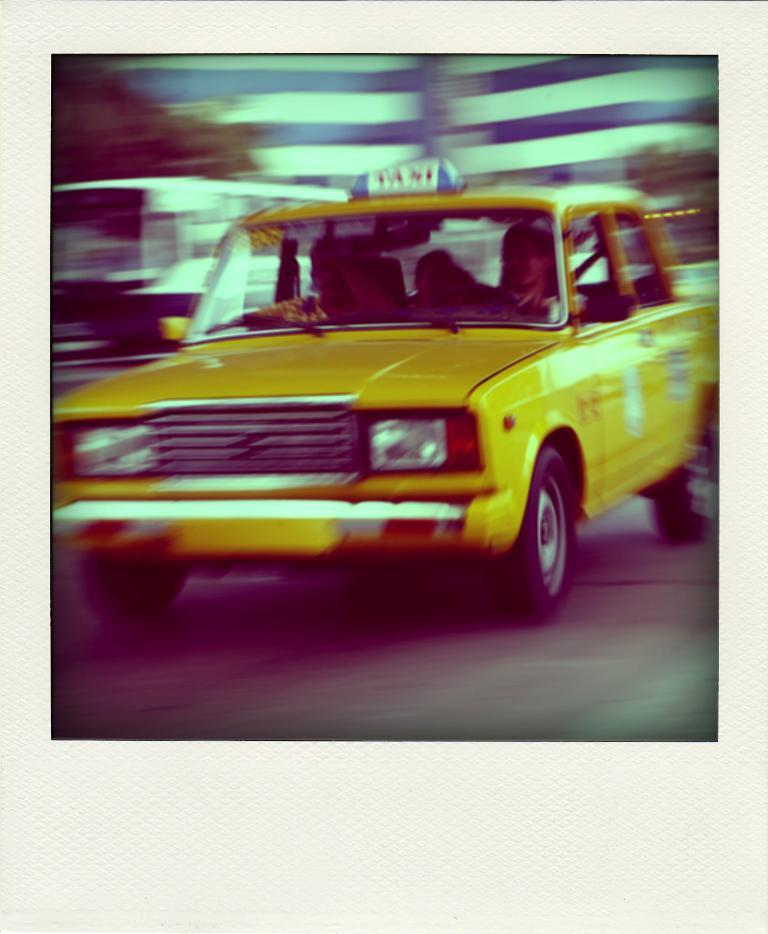<image>
Summarize the visual content of the image. A yellow car has a taxi sign on the roof. 